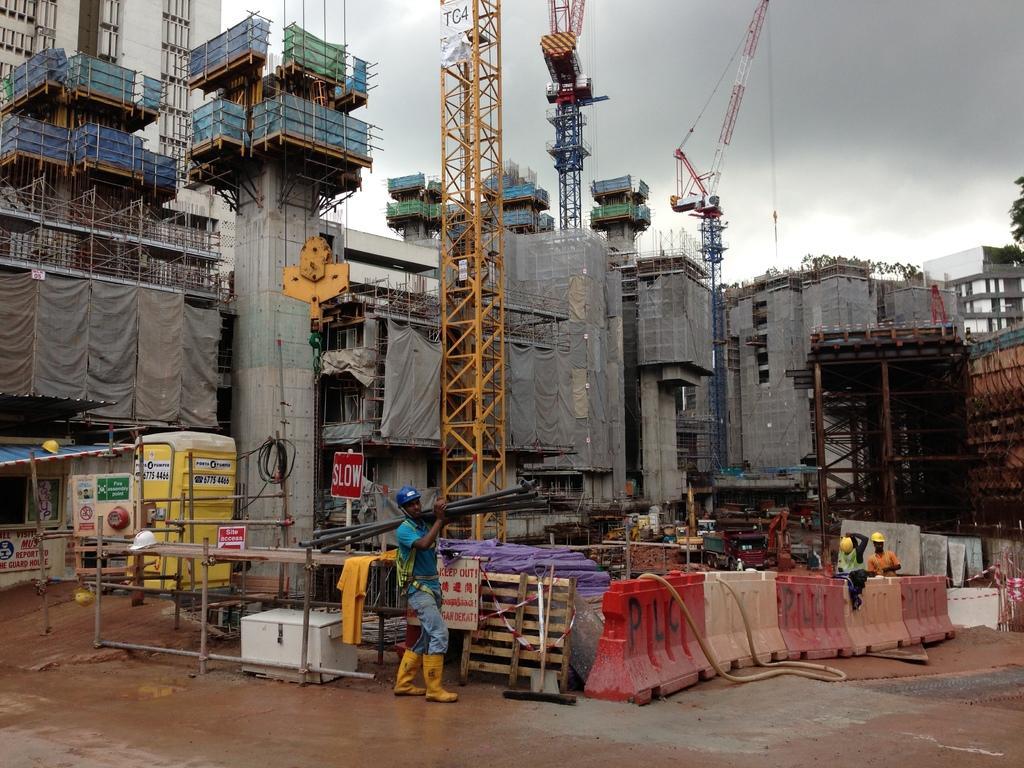Please provide a concise description of this image. In this image I can see the buildings which are under construction. In-front of the buildings I can see the cranes, boards, many wooden objects, pipes, dividers and the people. To the side I can see trees. In the background I can see the clouds and the sky. 